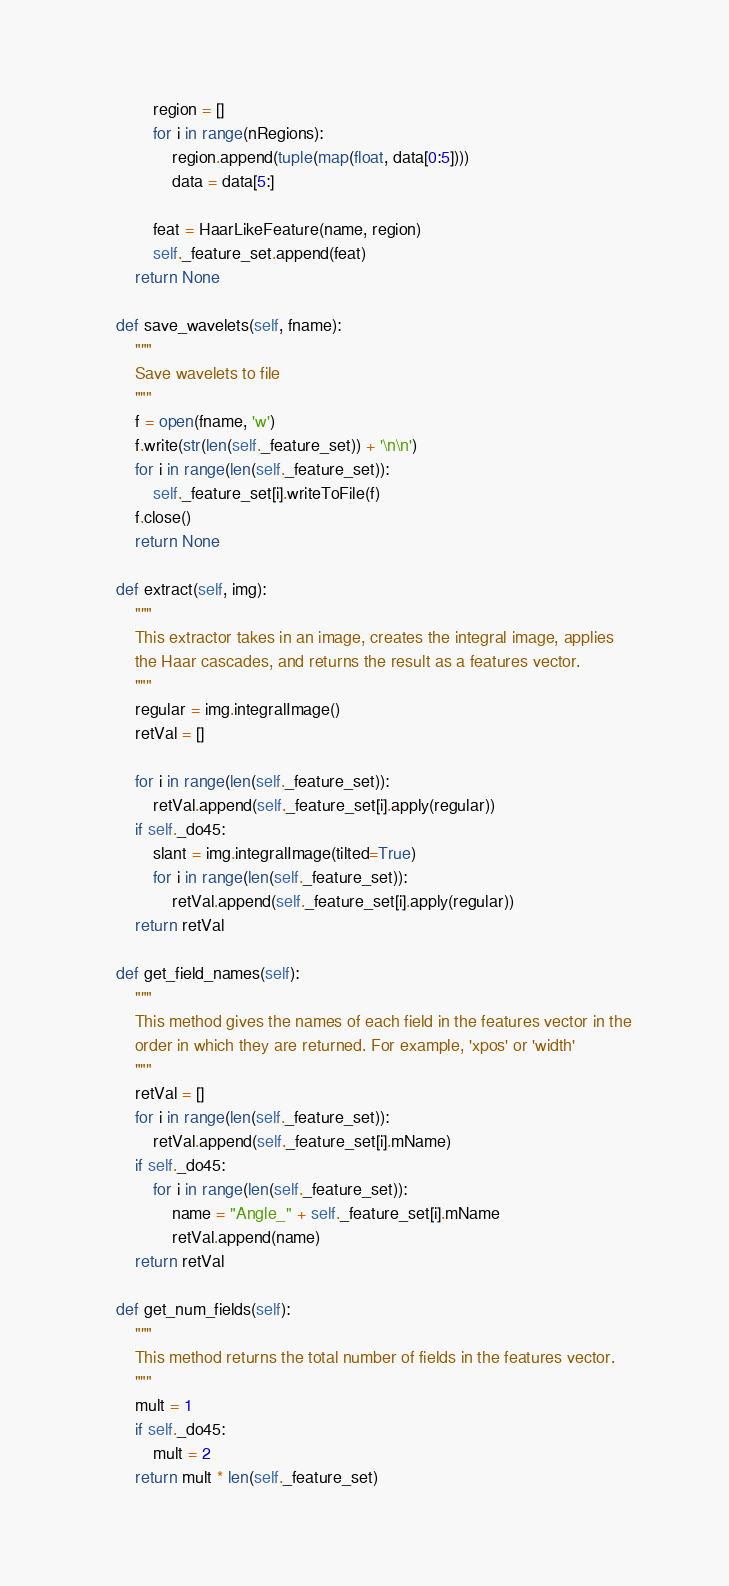<code> <loc_0><loc_0><loc_500><loc_500><_Python_>            region = []
            for i in range(nRegions):
                region.append(tuple(map(float, data[0:5])))
                data = data[5:]

            feat = HaarLikeFeature(name, region)
            self._feature_set.append(feat)
        return None

    def save_wavelets(self, fname):
        """
        Save wavelets to file
        """
        f = open(fname, 'w')
        f.write(str(len(self._feature_set)) + '\n\n')
        for i in range(len(self._feature_set)):
            self._feature_set[i].writeToFile(f)
        f.close()
        return None

    def extract(self, img):
        """
        This extractor takes in an image, creates the integral image, applies
        the Haar cascades, and returns the result as a features vector.
        """
        regular = img.integralImage()
        retVal = []

        for i in range(len(self._feature_set)):
            retVal.append(self._feature_set[i].apply(regular))
        if self._do45:
            slant = img.integralImage(tilted=True)
            for i in range(len(self._feature_set)):
                retVal.append(self._feature_set[i].apply(regular))
        return retVal

    def get_field_names(self):
        """
        This method gives the names of each field in the features vector in the
        order in which they are returned. For example, 'xpos' or 'width'
        """
        retVal = []
        for i in range(len(self._feature_set)):
            retVal.append(self._feature_set[i].mName)
        if self._do45:
            for i in range(len(self._feature_set)):
                name = "Angle_" + self._feature_set[i].mName
                retVal.append(name)
        return retVal

    def get_num_fields(self):
        """
        This method returns the total number of fields in the features vector.
        """
        mult = 1
        if self._do45:
            mult = 2
        return mult * len(self._feature_set)
</code> 